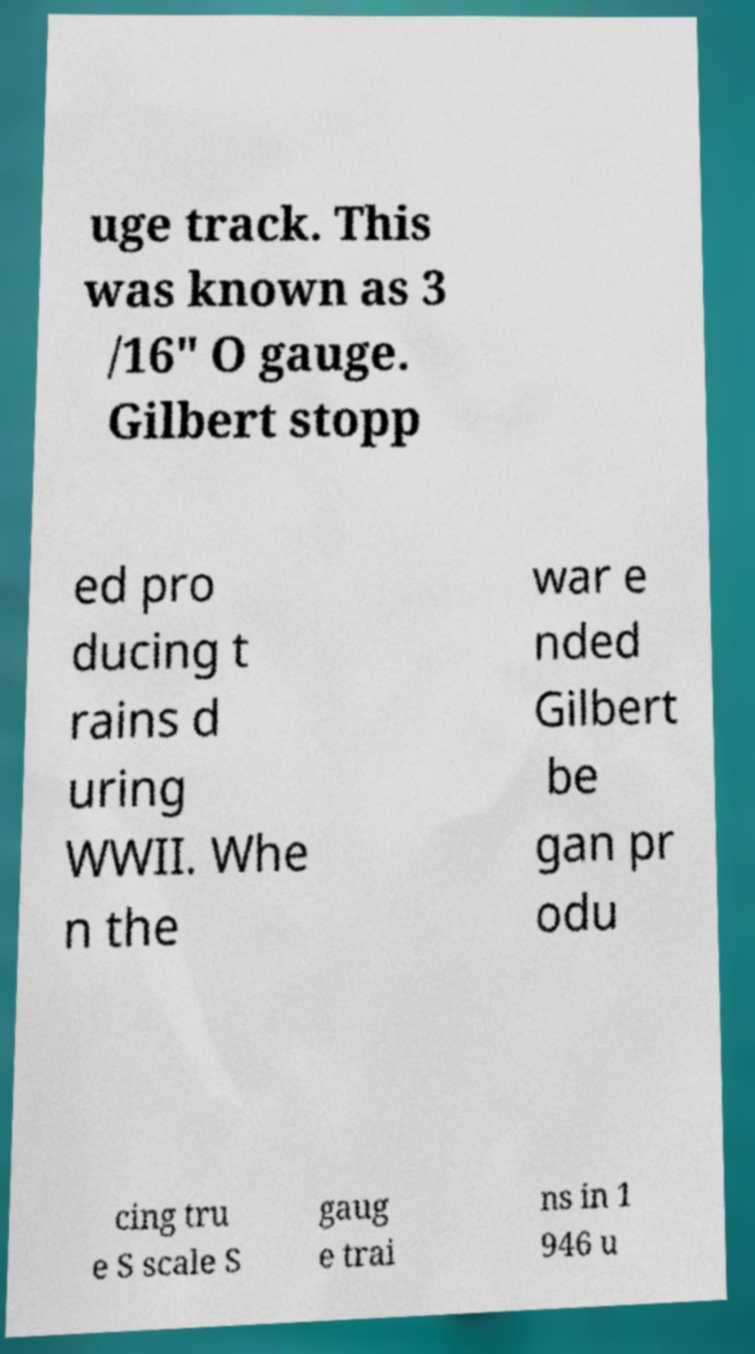Could you assist in decoding the text presented in this image and type it out clearly? uge track. This was known as 3 /16" O gauge. Gilbert stopp ed pro ducing t rains d uring WWII. Whe n the war e nded Gilbert be gan pr odu cing tru e S scale S gaug e trai ns in 1 946 u 